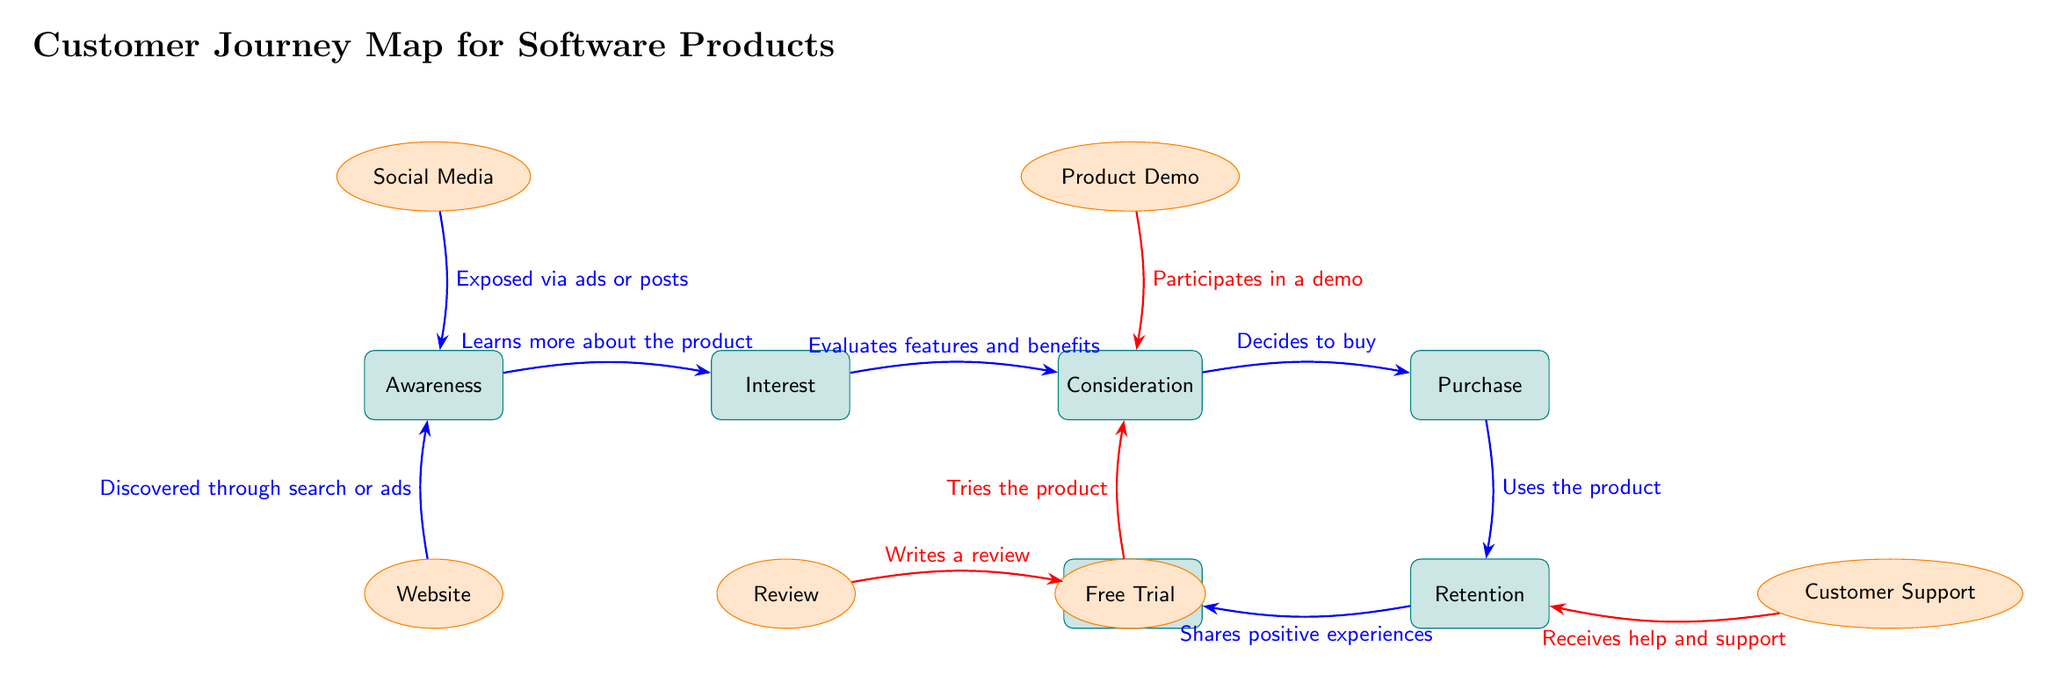What is the first stage in the customer journey? The first stage listed in the diagram is "Awareness." This is identified as the starting point of the customer journey, shown at the top left corner.
Answer: Awareness How many touchpoints are shown in the diagram? The diagram includes a total of six distinct touchpoints, which are social media, website, product demo, free trial, customer support, and review. These touchpoints are represented with ellipses positioned above and below various stages of the journey.
Answer: 6 Which touchpoint is associated with 'Exposed via ads or posts'? The touchpoint linked to the phrase "Exposed via ads or posts" is "Social Media." This phrase connects directly to the awareness stage, indicating how customers first learn about the product.
Answer: Social Media What stage follows 'Consideration'? The stage that follows "Consideration" is "Purchase." This is directly indicated in the flow of the diagram where the arrows depict progression from one stage to the next.
Answer: Purchase What is the connection between 'Customer Support' and 'Retention'? "Customer Support" connects to "Retention" via the phrase "Receives help and support." This indicates that after the purchase stage, customers receive assistance, which is crucial for their ongoing retention.
Answer: Receives help and support What emotion or action is associated with the 'Advocacy' stage? The action associated with "Advocacy" is "Shares positive experiences." This implies that customers who have had favorable experiences tend to advocate for the product by sharing those experiences with others.
Answer: Shares positive experiences Which stage directly leads to 'Advocacy'? "Retention" directly leads to "Advocacy." This connection shows that maintaining a positive relationship with customers encourages them to become advocates for the product.
Answer: Retention What are the two touchpoints mentioned under 'Consideration'? The two touchpoints associated with the "Consideration" stage are "Product Demo" and "Free Trial." These touchpoints are designed to provide potential customers with hands-on experience or demonstrations of the product.
Answer: Product Demo and Free Trial Where does the 'Website' touchpoint fall in the customer journey? The "Website" touchpoint is positioned below the "Awareness" stage. It signifies a source through which potential customers discover the product, emphasizing its role in initiating interest.
Answer: Below Awareness 